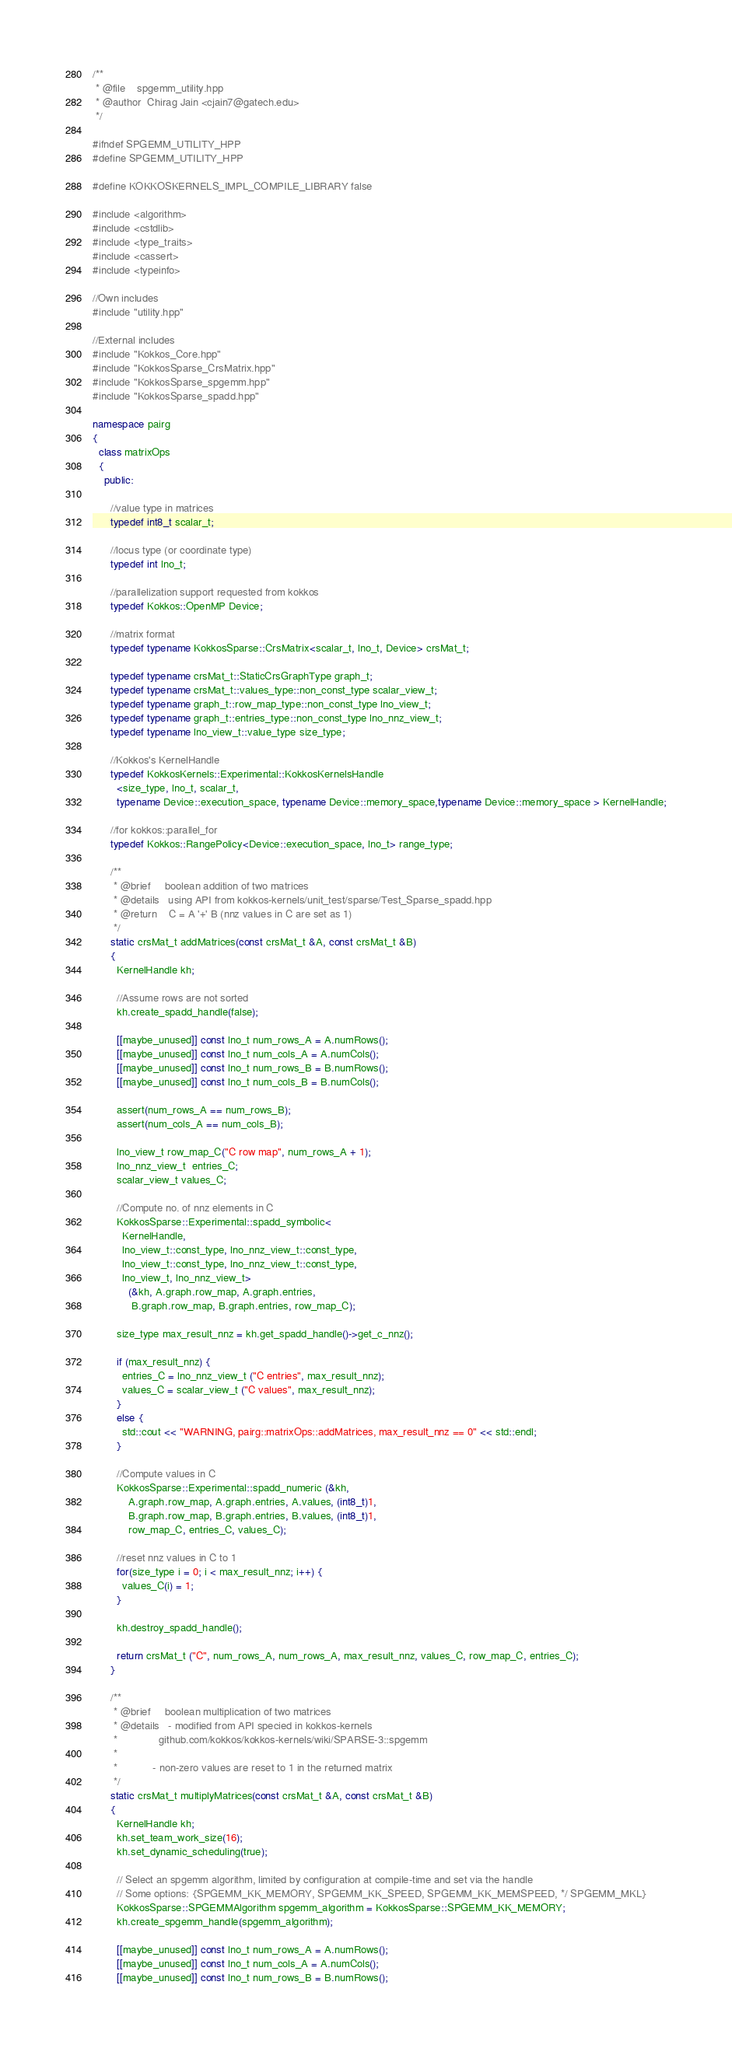<code> <loc_0><loc_0><loc_500><loc_500><_C++_>/**
 * @file    spgemm_utility.hpp
 * @author  Chirag Jain <cjain7@gatech.edu>
 */

#ifndef SPGEMM_UTILITY_HPP
#define SPGEMM_UTILITY_HPP

#define KOKKOSKERNELS_IMPL_COMPILE_LIBRARY false

#include <algorithm>   
#include <cstdlib>     
#include <type_traits>
#include <cassert>
#include <typeinfo> 

//Own includes
#include "utility.hpp" 

//External includes
#include "Kokkos_Core.hpp"
#include "KokkosSparse_CrsMatrix.hpp"
#include "KokkosSparse_spgemm.hpp"
#include "KokkosSparse_spadd.hpp"

namespace pairg
{
  class matrixOps
  {
    public:

      //value type in matrices
      typedef int8_t scalar_t;

      //locus type (or coordinate type)
      typedef int lno_t;

      //parallelization support requested from kokkos
      typedef Kokkos::OpenMP Device;

      //matrix format
      typedef typename KokkosSparse::CrsMatrix<scalar_t, lno_t, Device> crsMat_t;

      typedef typename crsMat_t::StaticCrsGraphType graph_t;
      typedef typename crsMat_t::values_type::non_const_type scalar_view_t;
      typedef typename graph_t::row_map_type::non_const_type lno_view_t;
      typedef typename graph_t::entries_type::non_const_type lno_nnz_view_t;
      typedef typename lno_view_t::value_type size_type;

      //Kokkos's KernelHandle
      typedef KokkosKernels::Experimental::KokkosKernelsHandle
        <size_type, lno_t, scalar_t,
        typename Device::execution_space, typename Device::memory_space,typename Device::memory_space > KernelHandle;

      //for kokkos::parallel_for
      typedef Kokkos::RangePolicy<Device::execution_space, lno_t> range_type;

      /**
       * @brief     boolean addition of two matrices 
       * @details   using API from kokkos-kernels/unit_test/sparse/Test_Sparse_spadd.hpp
       * @return    C = A '+' B (nnz values in C are set as 1)
       */
      static crsMat_t addMatrices(const crsMat_t &A, const crsMat_t &B)
      {
        KernelHandle kh; 

        //Assume rows are not sorted
        kh.create_spadd_handle(false);

        [[maybe_unused]] const lno_t num_rows_A = A.numRows();
        [[maybe_unused]] const lno_t num_cols_A = A.numCols();
        [[maybe_unused]] const lno_t num_rows_B = B.numRows();
        [[maybe_unused]] const lno_t num_cols_B = B.numCols();

        assert(num_rows_A == num_rows_B);
        assert(num_cols_A == num_cols_B);

        lno_view_t row_map_C("C row map", num_rows_A + 1);
        lno_nnz_view_t  entries_C;
        scalar_view_t values_C;

        //Compute no. of nnz elements in C
        KokkosSparse::Experimental::spadd_symbolic<
          KernelHandle, 
          lno_view_t::const_type, lno_nnz_view_t::const_type, 
          lno_view_t::const_type, lno_nnz_view_t::const_type, 
          lno_view_t, lno_nnz_view_t>
            (&kh, A.graph.row_map, A.graph.entries, 
             B.graph.row_map, B.graph.entries, row_map_C);

        size_type max_result_nnz = kh.get_spadd_handle()->get_c_nnz();

        if (max_result_nnz) {
          entries_C = lno_nnz_view_t ("C entries", max_result_nnz);
          values_C = scalar_view_t ("C values", max_result_nnz);
        }
        else {
          std::cout << "WARNING, pairg::matrixOps::addMatrices, max_result_nnz == 0" << std::endl;
        }

        //Compute values in C
        KokkosSparse::Experimental::spadd_numeric (&kh, 
            A.graph.row_map, A.graph.entries, A.values, (int8_t)1,
            B.graph.row_map, B.graph.entries, B.values, (int8_t)1,
            row_map_C, entries_C, values_C);

        //reset nnz values in C to 1
        for(size_type i = 0; i < max_result_nnz; i++) {
          values_C(i) = 1;
        }

        kh.destroy_spadd_handle();

        return crsMat_t ("C", num_rows_A, num_rows_A, max_result_nnz, values_C, row_map_C, entries_C);
      }

      /**
       * @brief     boolean multiplication of two matrices 
       * @details   - modified from API specied in kokkos-kernels
       *              github.com/kokkos/kokkos-kernels/wiki/SPARSE-3::spgemm 
       *
       *            - non-zero values are reset to 1 in the returned matrix
       */
      static crsMat_t multiplyMatrices(const crsMat_t &A, const crsMat_t &B)
      {
        KernelHandle kh; 
        kh.set_team_work_size(16);
        kh.set_dynamic_scheduling(true);

        // Select an spgemm algorithm, limited by configuration at compile-time and set via the handle
        // Some options: {SPGEMM_KK_MEMORY, SPGEMM_KK_SPEED, SPGEMM_KK_MEMSPEED, */ SPGEMM_MKL}
        KokkosSparse::SPGEMMAlgorithm spgemm_algorithm = KokkosSparse::SPGEMM_KK_MEMORY;
        kh.create_spgemm_handle(spgemm_algorithm);

        [[maybe_unused]] const lno_t num_rows_A = A.numRows();
        [[maybe_unused]] const lno_t num_cols_A = A.numCols();
        [[maybe_unused]] const lno_t num_rows_B = B.numRows();</code> 